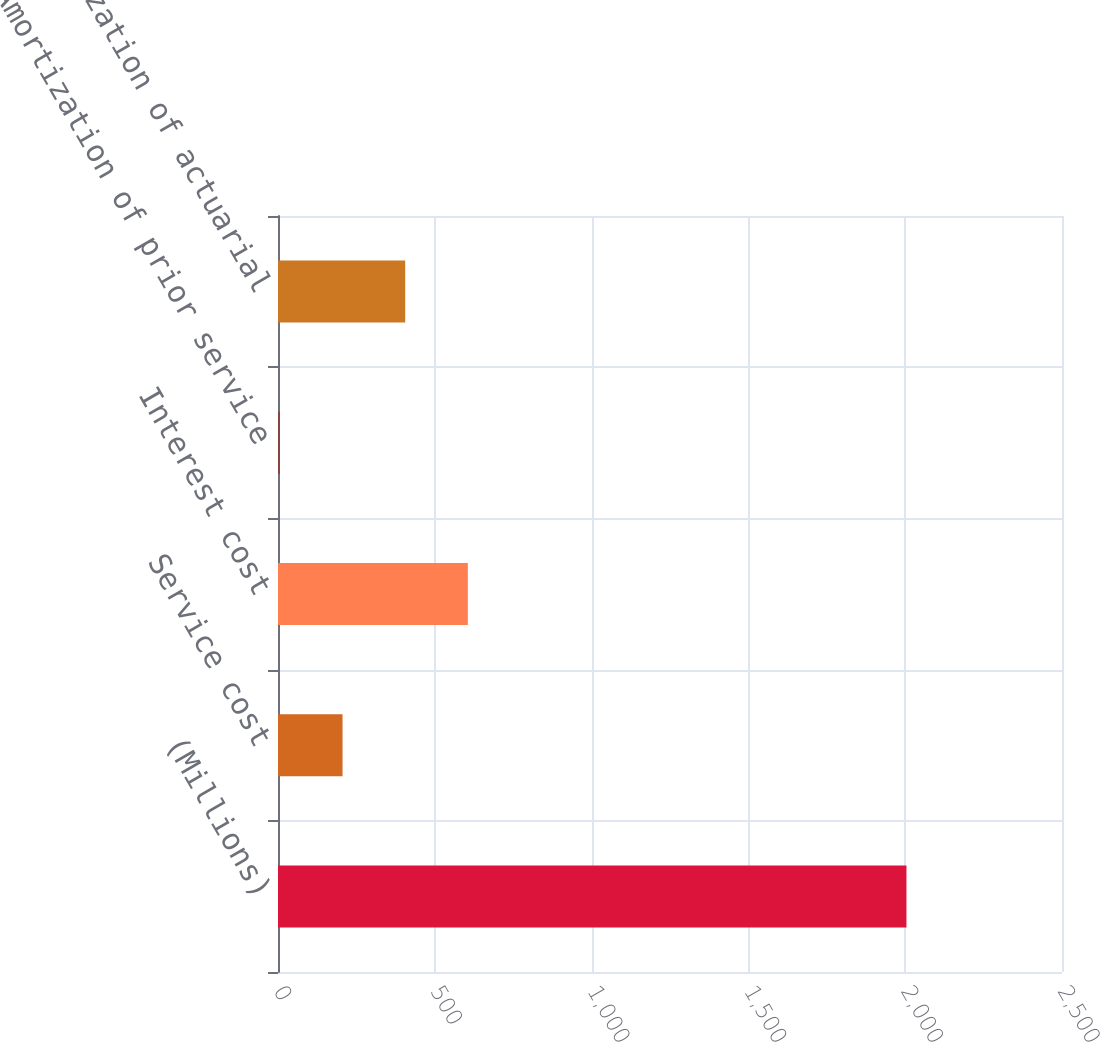Convert chart. <chart><loc_0><loc_0><loc_500><loc_500><bar_chart><fcel>(Millions)<fcel>Service cost<fcel>Interest cost<fcel>Amortization of prior service<fcel>Amortization of actuarial<nl><fcel>2004<fcel>205.8<fcel>605.4<fcel>6<fcel>405.6<nl></chart> 